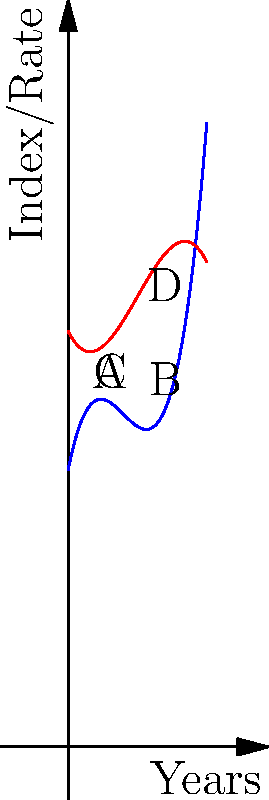The graph shows the relationship between a country's Human Rights Index (blue curve) and Economic Growth Rate (red curve) over a 5-year period. At which point does the Human Rights Index show the most rapid increase, and how does this correspond to the Economic Growth Rate at that same point? To answer this question, we need to analyze the blue curve (Human Rights Index) and identify the point of steepest increase. Then, we'll compare it to the red curve (Economic Growth Rate) at the same point.

Step 1: Identify the steepest part of the blue curve.
The blue curve shows the steepest increase between points A and B, with the maximum slope occurring approximately at the midpoint between these two points (around year 2.5).

Step 2: Locate the corresponding point on the red curve.
At the same x-coordinate (year 2.5), we find a point on the red curve that's between points C and D.

Step 3: Analyze the relationship.
At the point of steepest increase for the Human Rights Index, the Economic Growth Rate is showing a moderate increase, but not at its peak.

Step 4: Interpret the results.
This suggests that the most rapid improvement in human rights corresponds to a period of steady, but not maximum, economic growth. This aligns with theories that economic stability, rather than rapid growth, may be more conducive to human rights improvements.

Step 5: Consider the broader implications.
This relationship supports the idea that there's a complex interplay between human rights and economic development, where moderate, sustainable growth might be more beneficial for human rights than explosive economic expansion.
Answer: The Human Rights Index increases most rapidly around year 2.5, corresponding to a moderate increase in Economic Growth Rate. 